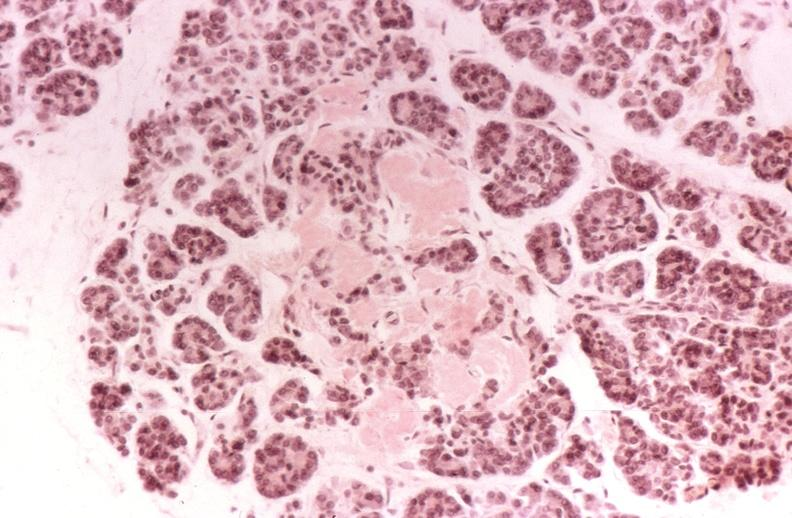where is this?
Answer the question using a single word or phrase. Pancreas 